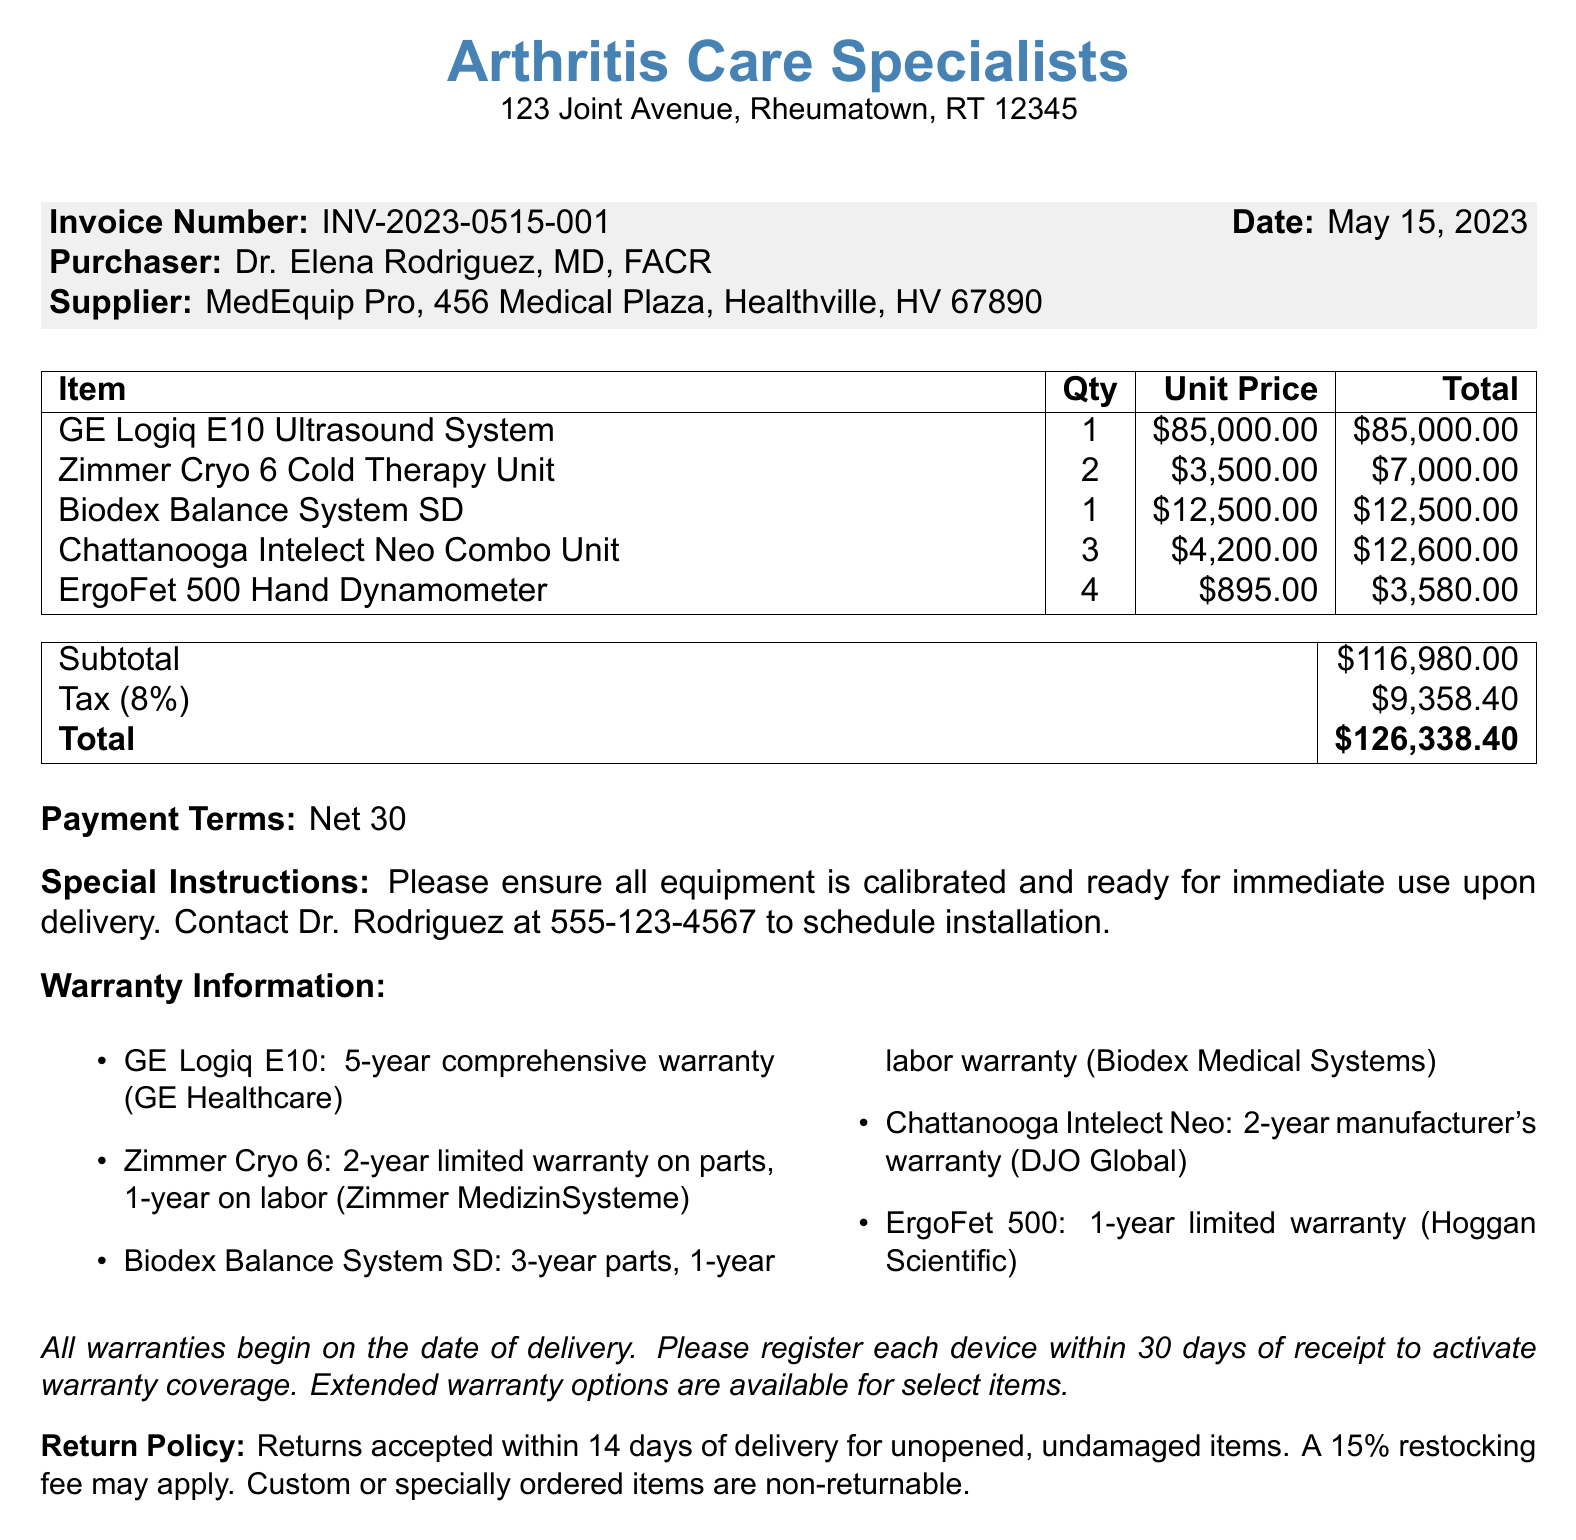What is the clinic name? The clinic name is mentioned at the top of the document, which is clearly stated as "Arthritis Care Specialists."
Answer: Arthritis Care Specialists Who is the purchaser? The purchaser's name appears in the invoice section and is "Dr. Elena Rodriguez, MD, FACR."
Answer: Dr. Elena Rodriguez, MD, FACR What is the total amount due? The total amount is the final total listed at the bottom of the invoice, which sums the subtotal and tax.
Answer: $126,338.40 What is the warranty for the GE Logiq E10 Ultrasound System? The document specifies that the warranty for this item is "5-year comprehensive warranty, including parts and labor."
Answer: 5-year comprehensive warranty, including parts and labor How many Zimmer Cryo 6 Cold Therapy Units were purchased? The quantity of this item is indicated in the items section of the document.
Answer: 2 What is the tax rate applied? The tax rate is explicitly stated in the document section showing the breakdown of costs.
Answer: 8% What is the return policy stated in the document? The return policy describes the conditions under which returns can be made and fees involved.
Answer: Returns accepted within 14 days of delivery for unopened, undamaged items. A 15% restocking fee may apply What special instructions were provided for the delivery? The special instructions highlight what is expected upon delivery of the equipment.
Answer: Please ensure all equipment is calibrated and ready for immediate use upon delivery What is the warranty provider for the Chattanooga Intelect Neo Combo Unit? The warranty provider for this item is mentioned in the warranty information section.
Answer: DJO Global 